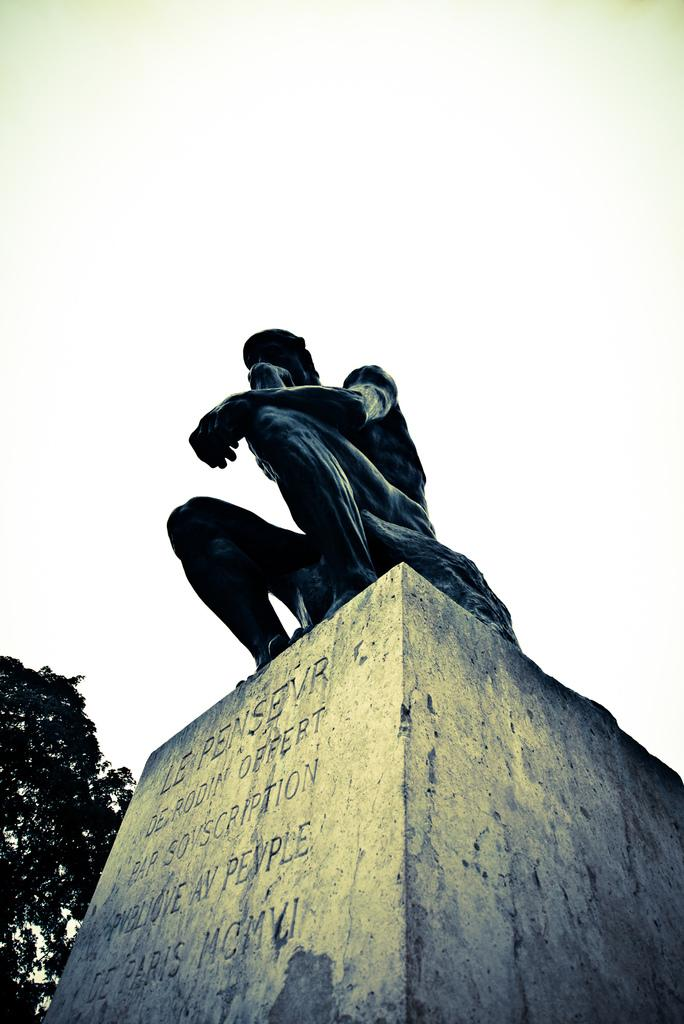What is the main subject in the middle of the image? There is a statue in the middle of the image. What can be seen on the left side of the image? There is a tree on the left side of the image. What is visible at the top of the image? The sky is visible at the top of the image. Can you tell me how many drawers are in the statue? There are no drawers present in the statue; it is a solid structure. Is the statue located near a seashore in the image? There is no information about a seashore in the image, as it only features a statue, a tree, and the sky. 